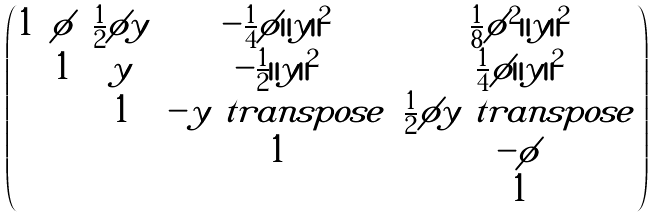<formula> <loc_0><loc_0><loc_500><loc_500>\begin{pmatrix} 1 & \phi & \frac { 1 } { 2 } \phi y & - \frac { 1 } { 4 } \phi \| y \| ^ { 2 } & \frac { 1 } { 8 } \phi ^ { 2 } \| y \| ^ { 2 } \\ & 1 & y & - \frac { 1 } { 2 } \| y \| ^ { 2 } & \frac { 1 } { 4 } \phi \| y \| ^ { 2 } \\ & & 1 & - y ^ { \ } t r a n s p o s e & \frac { 1 } { 2 } \phi y ^ { \ } t r a n s p o s e \\ & & & 1 & - \phi \\ & & & & 1 \\ \end{pmatrix}</formula> 